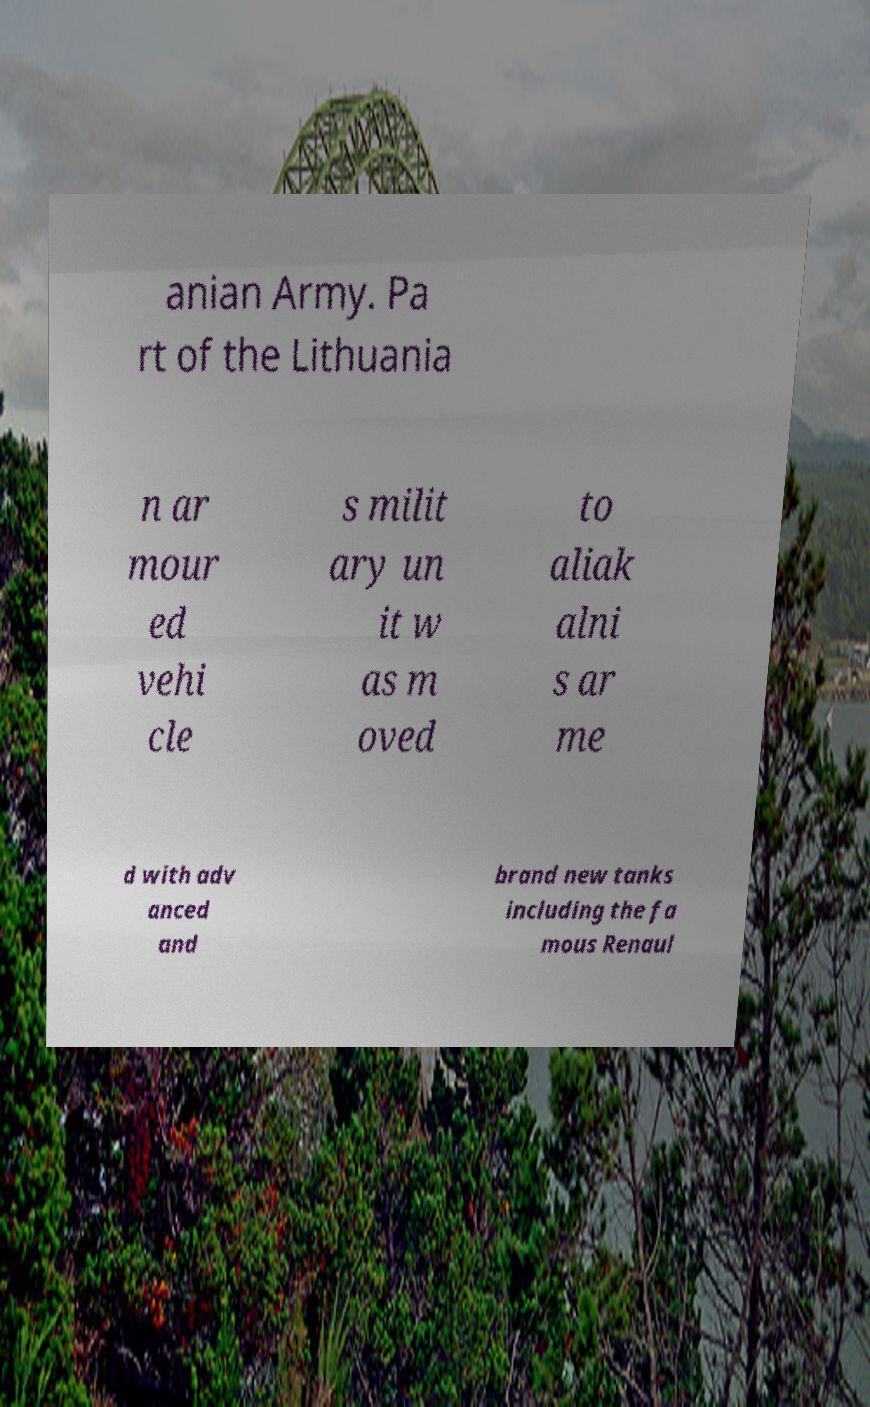What messages or text are displayed in this image? I need them in a readable, typed format. anian Army. Pa rt of the Lithuania n ar mour ed vehi cle s milit ary un it w as m oved to aliak alni s ar me d with adv anced and brand new tanks including the fa mous Renaul 